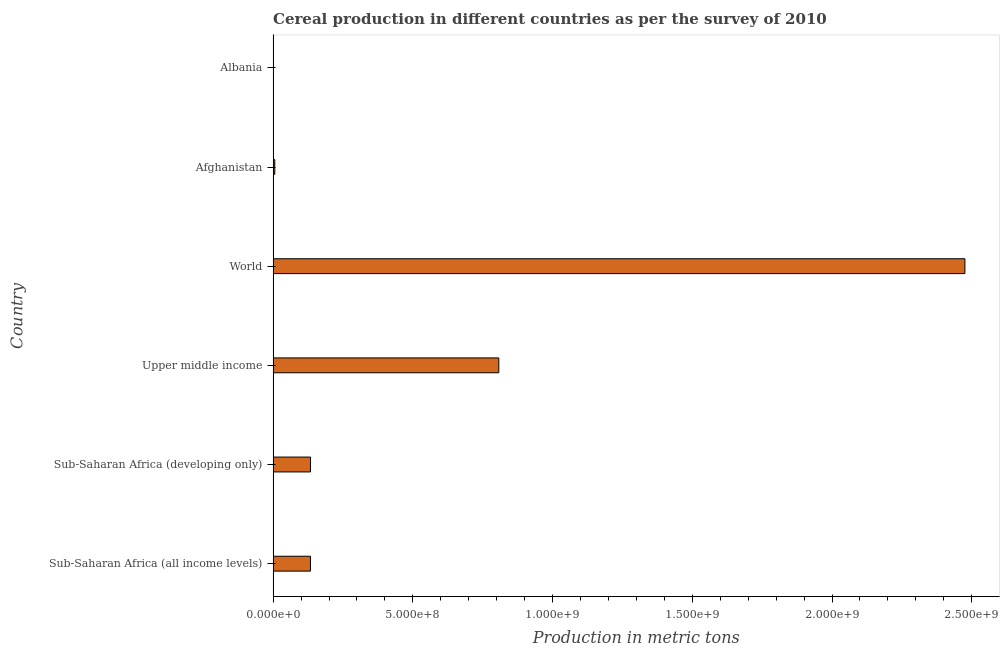Does the graph contain grids?
Provide a short and direct response. No. What is the title of the graph?
Give a very brief answer. Cereal production in different countries as per the survey of 2010. What is the label or title of the X-axis?
Make the answer very short. Production in metric tons. What is the label or title of the Y-axis?
Your answer should be compact. Country. What is the cereal production in Upper middle income?
Give a very brief answer. 8.08e+08. Across all countries, what is the maximum cereal production?
Give a very brief answer. 2.48e+09. Across all countries, what is the minimum cereal production?
Give a very brief answer. 6.94e+05. In which country was the cereal production minimum?
Offer a very short reply. Albania. What is the sum of the cereal production?
Make the answer very short. 3.56e+09. What is the difference between the cereal production in Sub-Saharan Africa (all income levels) and World?
Offer a terse response. -2.34e+09. What is the average cereal production per country?
Your answer should be compact. 5.93e+08. What is the median cereal production?
Offer a terse response. 1.34e+08. What is the ratio of the cereal production in Afghanistan to that in World?
Offer a terse response. 0. Is the cereal production in Albania less than that in Upper middle income?
Offer a very short reply. Yes. What is the difference between the highest and the second highest cereal production?
Your answer should be compact. 1.67e+09. Is the sum of the cereal production in Afghanistan and Upper middle income greater than the maximum cereal production across all countries?
Give a very brief answer. No. What is the difference between the highest and the lowest cereal production?
Keep it short and to the point. 2.47e+09. In how many countries, is the cereal production greater than the average cereal production taken over all countries?
Give a very brief answer. 2. Are all the bars in the graph horizontal?
Your answer should be compact. Yes. Are the values on the major ticks of X-axis written in scientific E-notation?
Your answer should be compact. Yes. What is the Production in metric tons of Sub-Saharan Africa (all income levels)?
Your answer should be very brief. 1.34e+08. What is the Production in metric tons in Sub-Saharan Africa (developing only)?
Offer a very short reply. 1.34e+08. What is the Production in metric tons in Upper middle income?
Your answer should be very brief. 8.08e+08. What is the Production in metric tons in World?
Your response must be concise. 2.48e+09. What is the Production in metric tons in Afghanistan?
Your answer should be very brief. 5.96e+06. What is the Production in metric tons of Albania?
Keep it short and to the point. 6.94e+05. What is the difference between the Production in metric tons in Sub-Saharan Africa (all income levels) and Upper middle income?
Give a very brief answer. -6.74e+08. What is the difference between the Production in metric tons in Sub-Saharan Africa (all income levels) and World?
Ensure brevity in your answer.  -2.34e+09. What is the difference between the Production in metric tons in Sub-Saharan Africa (all income levels) and Afghanistan?
Provide a short and direct response. 1.28e+08. What is the difference between the Production in metric tons in Sub-Saharan Africa (all income levels) and Albania?
Keep it short and to the point. 1.33e+08. What is the difference between the Production in metric tons in Sub-Saharan Africa (developing only) and Upper middle income?
Provide a short and direct response. -6.74e+08. What is the difference between the Production in metric tons in Sub-Saharan Africa (developing only) and World?
Provide a succinct answer. -2.34e+09. What is the difference between the Production in metric tons in Sub-Saharan Africa (developing only) and Afghanistan?
Your answer should be compact. 1.28e+08. What is the difference between the Production in metric tons in Sub-Saharan Africa (developing only) and Albania?
Give a very brief answer. 1.33e+08. What is the difference between the Production in metric tons in Upper middle income and World?
Your response must be concise. -1.67e+09. What is the difference between the Production in metric tons in Upper middle income and Afghanistan?
Provide a succinct answer. 8.02e+08. What is the difference between the Production in metric tons in Upper middle income and Albania?
Offer a very short reply. 8.07e+08. What is the difference between the Production in metric tons in World and Afghanistan?
Your answer should be compact. 2.47e+09. What is the difference between the Production in metric tons in World and Albania?
Offer a terse response. 2.47e+09. What is the difference between the Production in metric tons in Afghanistan and Albania?
Your response must be concise. 5.26e+06. What is the ratio of the Production in metric tons in Sub-Saharan Africa (all income levels) to that in Upper middle income?
Offer a terse response. 0.17. What is the ratio of the Production in metric tons in Sub-Saharan Africa (all income levels) to that in World?
Provide a short and direct response. 0.05. What is the ratio of the Production in metric tons in Sub-Saharan Africa (all income levels) to that in Afghanistan?
Give a very brief answer. 22.43. What is the ratio of the Production in metric tons in Sub-Saharan Africa (all income levels) to that in Albania?
Your response must be concise. 192.6. What is the ratio of the Production in metric tons in Sub-Saharan Africa (developing only) to that in Upper middle income?
Give a very brief answer. 0.17. What is the ratio of the Production in metric tons in Sub-Saharan Africa (developing only) to that in World?
Provide a short and direct response. 0.05. What is the ratio of the Production in metric tons in Sub-Saharan Africa (developing only) to that in Afghanistan?
Give a very brief answer. 22.43. What is the ratio of the Production in metric tons in Sub-Saharan Africa (developing only) to that in Albania?
Your answer should be very brief. 192.6. What is the ratio of the Production in metric tons in Upper middle income to that in World?
Your answer should be compact. 0.33. What is the ratio of the Production in metric tons in Upper middle income to that in Afghanistan?
Give a very brief answer. 135.58. What is the ratio of the Production in metric tons in Upper middle income to that in Albania?
Ensure brevity in your answer.  1164.08. What is the ratio of the Production in metric tons in World to that in Afghanistan?
Provide a short and direct response. 415.58. What is the ratio of the Production in metric tons in World to that in Albania?
Offer a terse response. 3568.2. What is the ratio of the Production in metric tons in Afghanistan to that in Albania?
Offer a terse response. 8.59. 